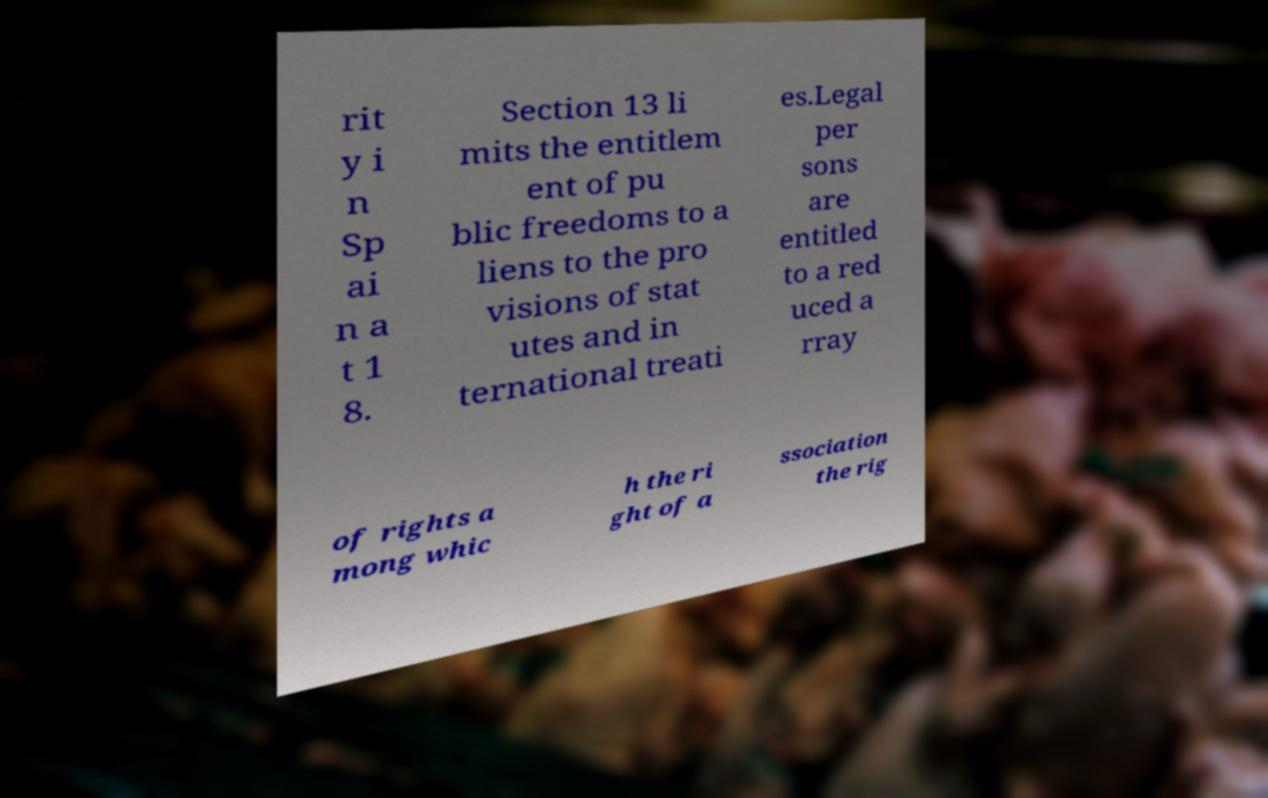There's text embedded in this image that I need extracted. Can you transcribe it verbatim? rit y i n Sp ai n a t 1 8. Section 13 li mits the entitlem ent of pu blic freedoms to a liens to the pro visions of stat utes and in ternational treati es.Legal per sons are entitled to a red uced a rray of rights a mong whic h the ri ght of a ssociation the rig 